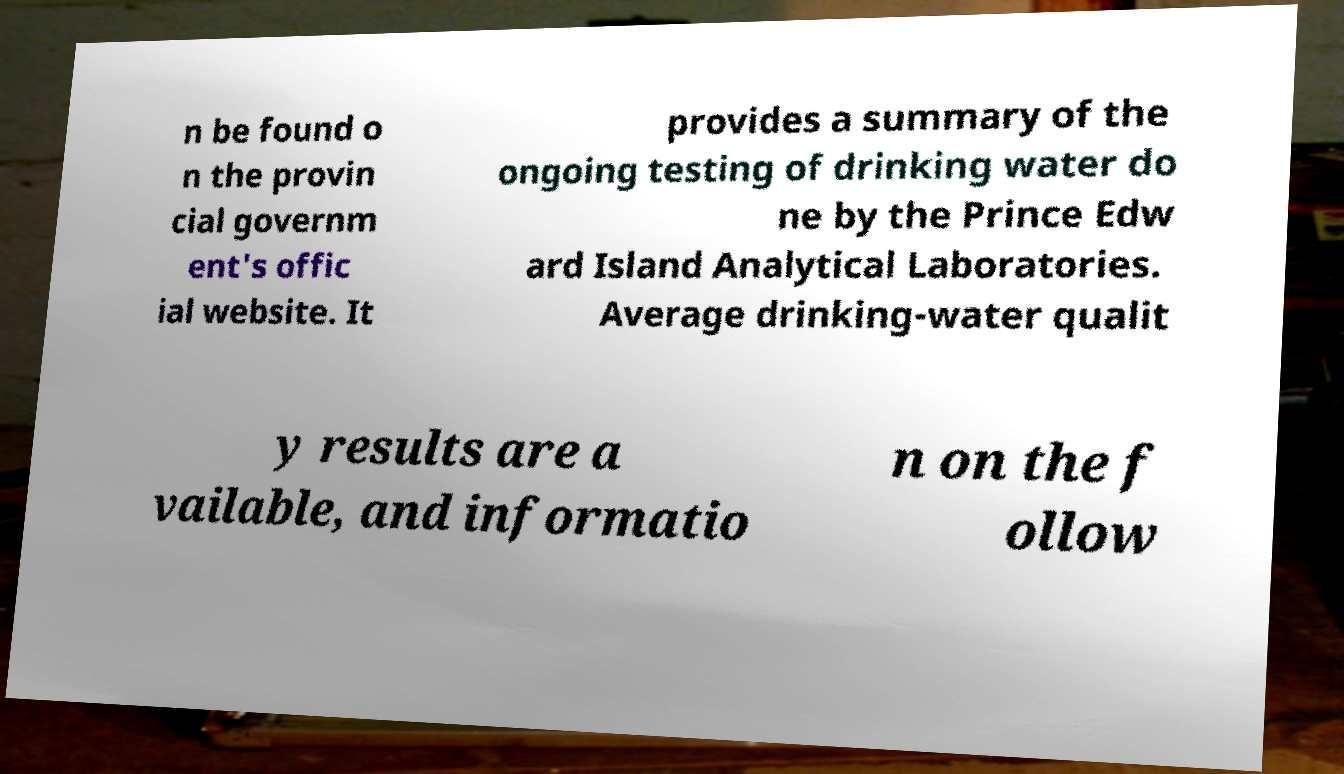Could you assist in decoding the text presented in this image and type it out clearly? n be found o n the provin cial governm ent's offic ial website. It provides a summary of the ongoing testing of drinking water do ne by the Prince Edw ard Island Analytical Laboratories. Average drinking-water qualit y results are a vailable, and informatio n on the f ollow 